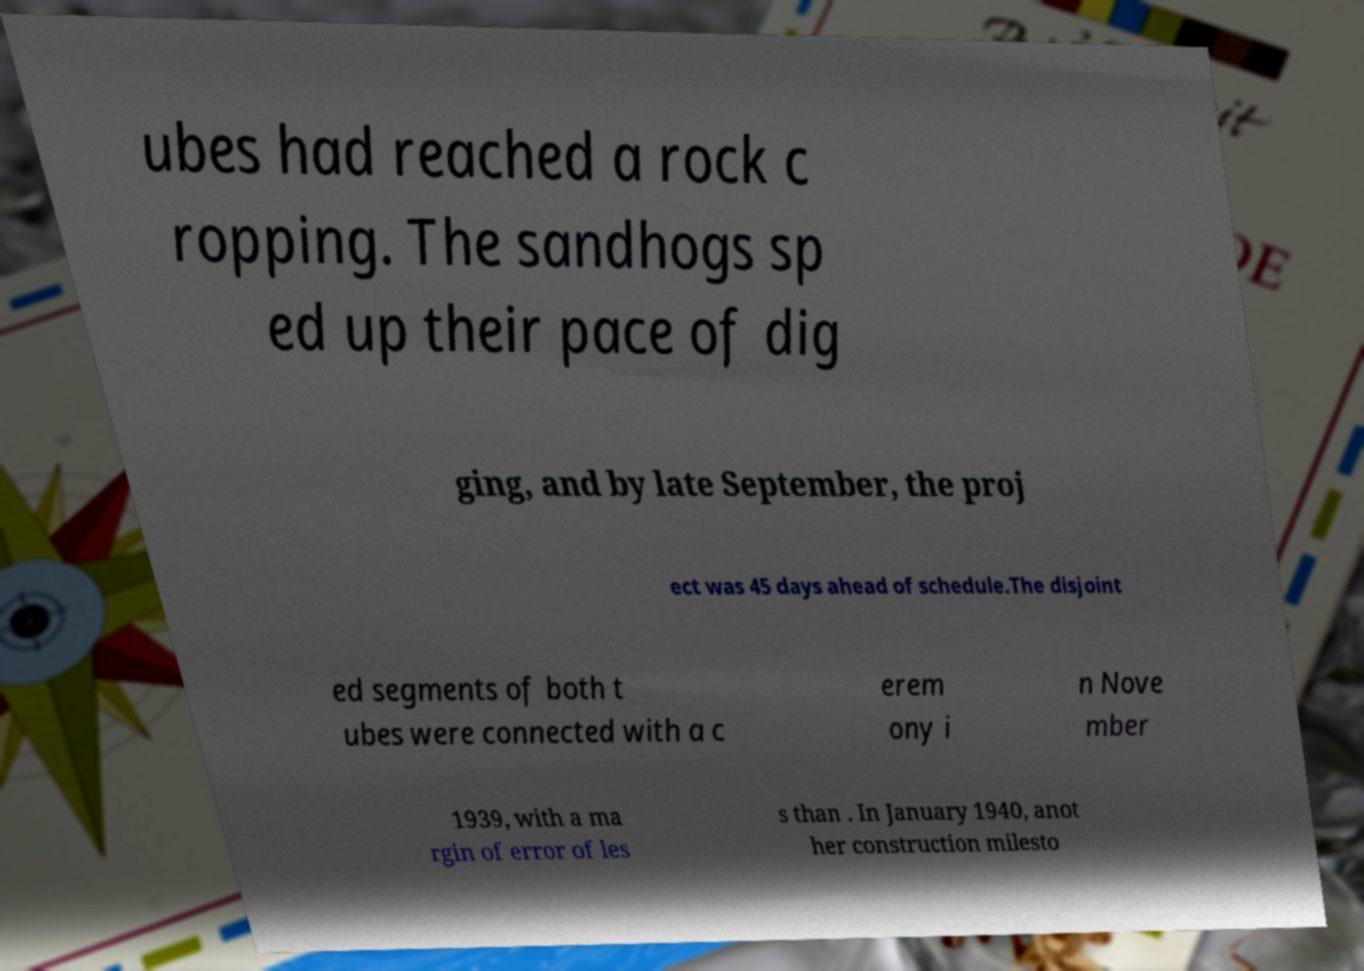Could you extract and type out the text from this image? ubes had reached a rock c ropping. The sandhogs sp ed up their pace of dig ging, and by late September, the proj ect was 45 days ahead of schedule.The disjoint ed segments of both t ubes were connected with a c erem ony i n Nove mber 1939, with a ma rgin of error of les s than . In January 1940, anot her construction milesto 